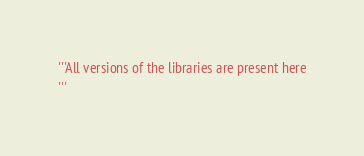Convert code to text. <code><loc_0><loc_0><loc_500><loc_500><_Python_>'''All versions of the libraries are present here
'''</code> 